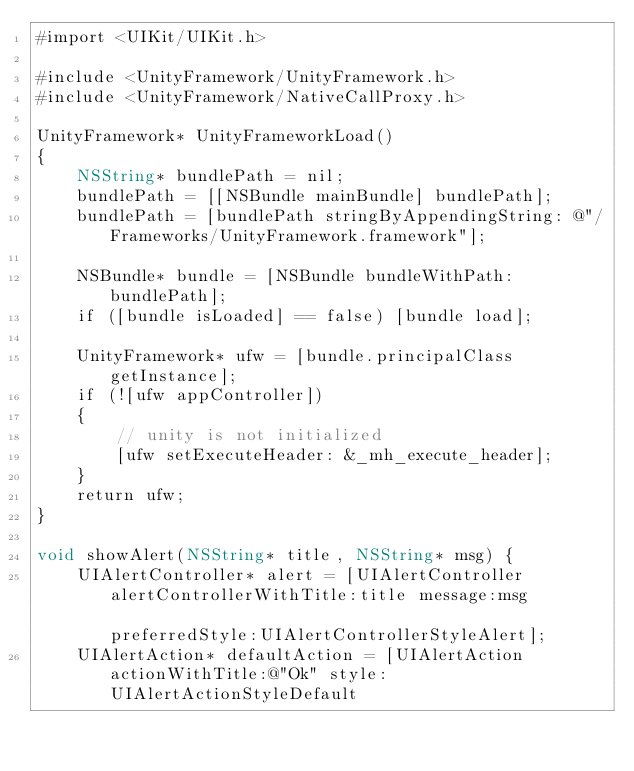Convert code to text. <code><loc_0><loc_0><loc_500><loc_500><_ObjectiveC_>#import <UIKit/UIKit.h>

#include <UnityFramework/UnityFramework.h>
#include <UnityFramework/NativeCallProxy.h>

UnityFramework* UnityFrameworkLoad()
{
    NSString* bundlePath = nil;
    bundlePath = [[NSBundle mainBundle] bundlePath];
    bundlePath = [bundlePath stringByAppendingString: @"/Frameworks/UnityFramework.framework"];
    
    NSBundle* bundle = [NSBundle bundleWithPath: bundlePath];
    if ([bundle isLoaded] == false) [bundle load];
    
    UnityFramework* ufw = [bundle.principalClass getInstance];
    if (![ufw appController])
    {
        // unity is not initialized
        [ufw setExecuteHeader: &_mh_execute_header];
    }
    return ufw;
}

void showAlert(NSString* title, NSString* msg) {
    UIAlertController* alert = [UIAlertController alertControllerWithTitle:title message:msg                                                         preferredStyle:UIAlertControllerStyleAlert];
    UIAlertAction* defaultAction = [UIAlertAction actionWithTitle:@"Ok" style:UIAlertActionStyleDefault</code> 